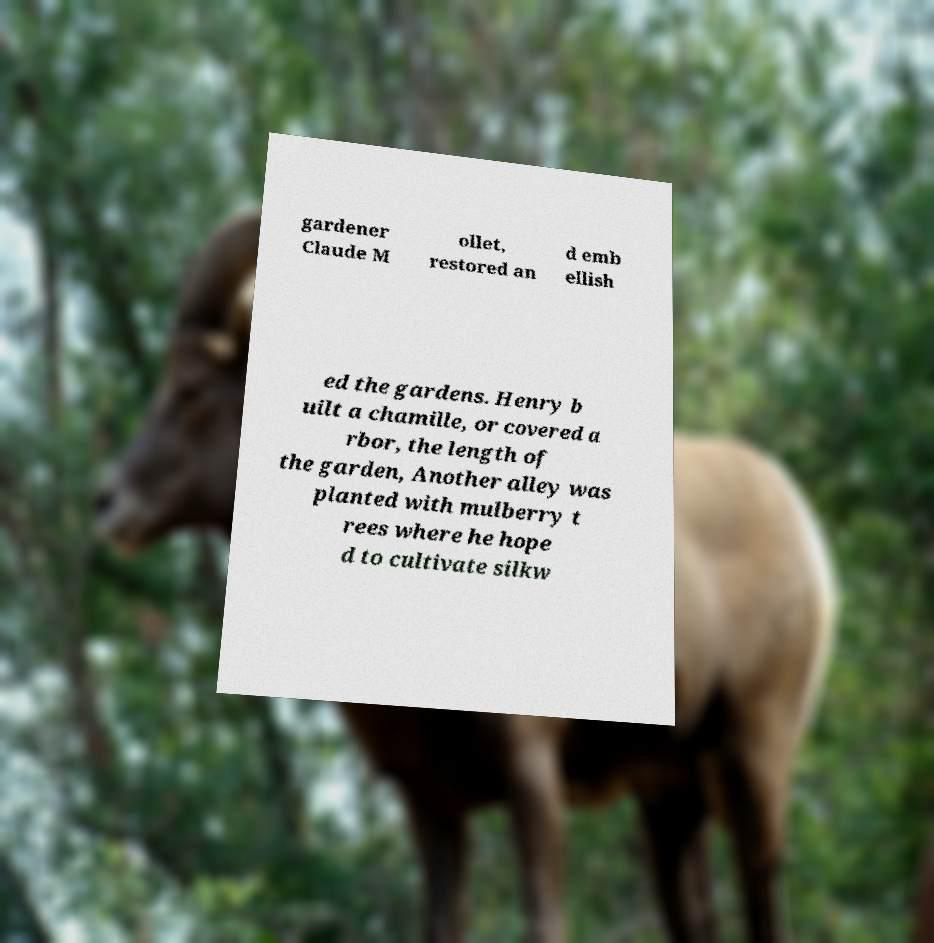Please identify and transcribe the text found in this image. gardener Claude M ollet, restored an d emb ellish ed the gardens. Henry b uilt a chamille, or covered a rbor, the length of the garden, Another alley was planted with mulberry t rees where he hope d to cultivate silkw 